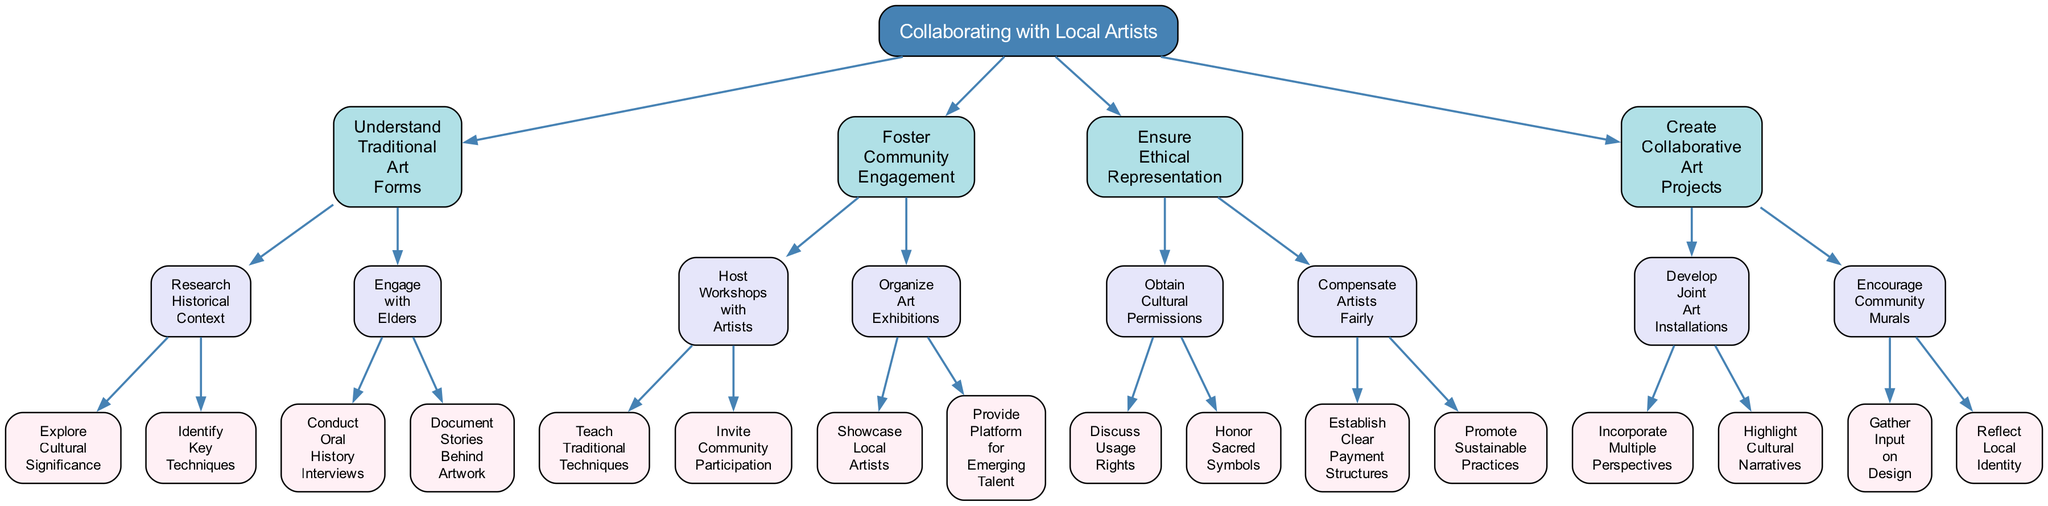What is the main focus of the first branch of the tree? The first branch of the tree represents "Understand Traditional Art Forms," which is the primary area of consideration for collaborating with local artists. This can be identified as it is the immediate child of the root node.
Answer: Understand Traditional Art Forms How many sub-branches does "Foster Community Engagement" have? Under the "Foster Community Engagement" node, there are two sub-branches: "Host Workshops with Artists" and "Organize Art Exhibitions." Therefore, counting these provides the total.
Answer: 2 What ethical consideration is emphasized regarding the representation of local culture? The node "Ensure Ethical Representation" specifically addresses this aspect, highlighting the importance of discussing usage rights and honoring sacred symbols to respect local culture.
Answer: Ensure Ethical Representation Which node includes "Conduct Oral History Interviews"? "Conduct Oral History Interviews" is a child node under "Engage with Elders," which is nested within "Understand Traditional Art Forms." Tracing the hierarchy from the root node to this specific node shows its position.
Answer: Engage with Elders What type of project is suggested under "Create Collaborative Art Projects"? The node suggests "Develop Joint Art Installations," which is focused on creating projects that involve multiple perspectives and highlight cultural narratives. This is determined by looking at the children of the "Create Collaborative Art Projects" node.
Answer: Joint Art Installations How many specific actions are listed under "Host Workshops with Artists"? "Host Workshops with Artists" has two specific actions listed: "Teach Traditional Techniques" and "Invite Community Participation." Counting these reveals the total number of actions.
Answer: 2 What is the goal of "Encourage Community Murals"? The intention behind "Encourage Community Murals" is to gather input on design and reflect local identity, showcasing the collaborative aspect of community-based art projects. This can be derived from the descriptions under that node.
Answer: Reflect Local Identity What element of community involvement is highlighted in the decision tree? The decision tree highlights "Community Participation" as a key aspect under "Host Workshops with Artists," emphasizing the importance of involving local community members in the artistic process. This can be traced by following the related nodes.
Answer: Community Participation What is one of the benefits of collaborating with local artists in exhibition efforts? One benefit is to "Showcase Local Artists," empowering them and providing visibility, which is emphasized in the "Organize Art Exhibitions" node. This benefit can be directly identified as a main action listed under the related branch.
Answer: Showcase Local Artists 